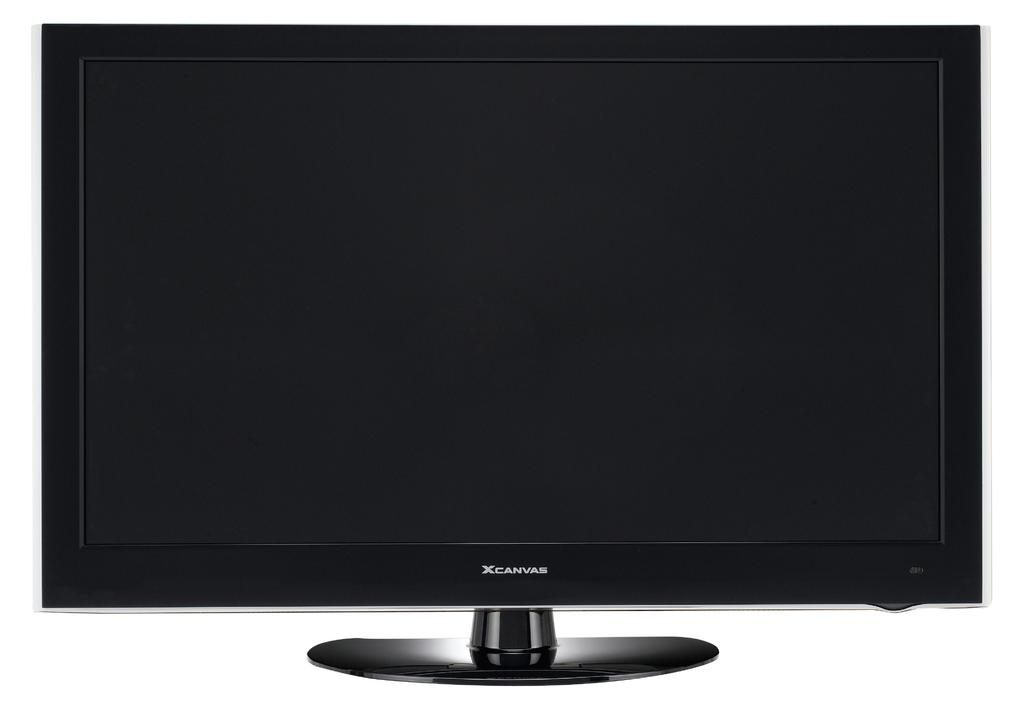<image>
Write a terse but informative summary of the picture. An XCanvas monitor is black and turned off. 